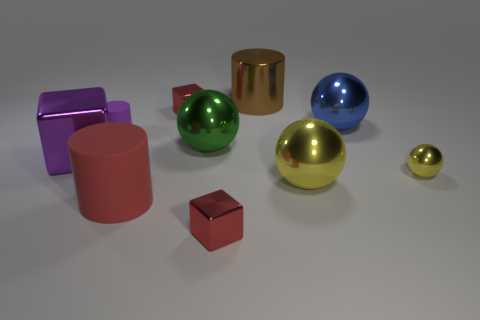What shape is the brown shiny object?
Your answer should be compact. Cylinder. What is the shape of the blue shiny thing that is to the right of the red metal object behind the big rubber object?
Your answer should be very brief. Sphere. There is a block that is the same color as the small rubber cylinder; what is its material?
Ensure brevity in your answer.  Metal. Are there the same number of large brown shiny cylinders and matte cylinders?
Your response must be concise. No. The big cylinder that is made of the same material as the large green ball is what color?
Give a very brief answer. Brown. Are there any other things that are the same size as the brown cylinder?
Your answer should be very brief. Yes. There is a sphere on the right side of the blue object; is it the same color as the big metal sphere on the left side of the big brown object?
Offer a very short reply. No. Is the number of tiny red metallic things in front of the small purple rubber thing greater than the number of small red objects in front of the large red object?
Your response must be concise. No. What is the color of the big matte thing that is the same shape as the small purple rubber object?
Ensure brevity in your answer.  Red. Are there any other things that have the same shape as the purple matte thing?
Provide a succinct answer. Yes. 